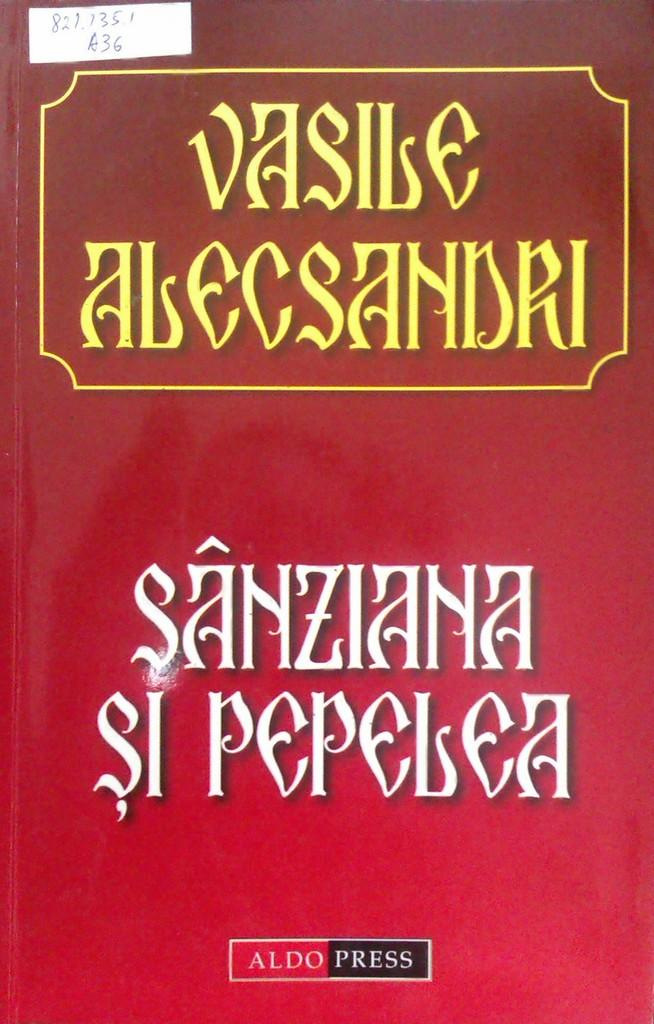<image>
Write a terse but informative summary of the picture. A book has the Aldo Press logo on the bottom of the cover. 